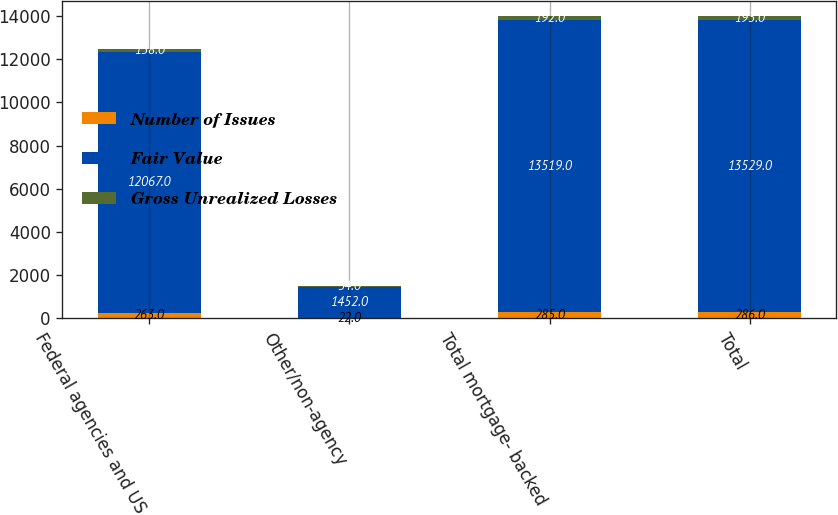<chart> <loc_0><loc_0><loc_500><loc_500><stacked_bar_chart><ecel><fcel>Federal agencies and US<fcel>Other/non-agency<fcel>Total mortgage- backed<fcel>Total<nl><fcel>Number of Issues<fcel>263<fcel>22<fcel>285<fcel>286<nl><fcel>Fair Value<fcel>12067<fcel>1452<fcel>13519<fcel>13529<nl><fcel>Gross Unrealized Losses<fcel>158<fcel>34<fcel>192<fcel>193<nl></chart> 